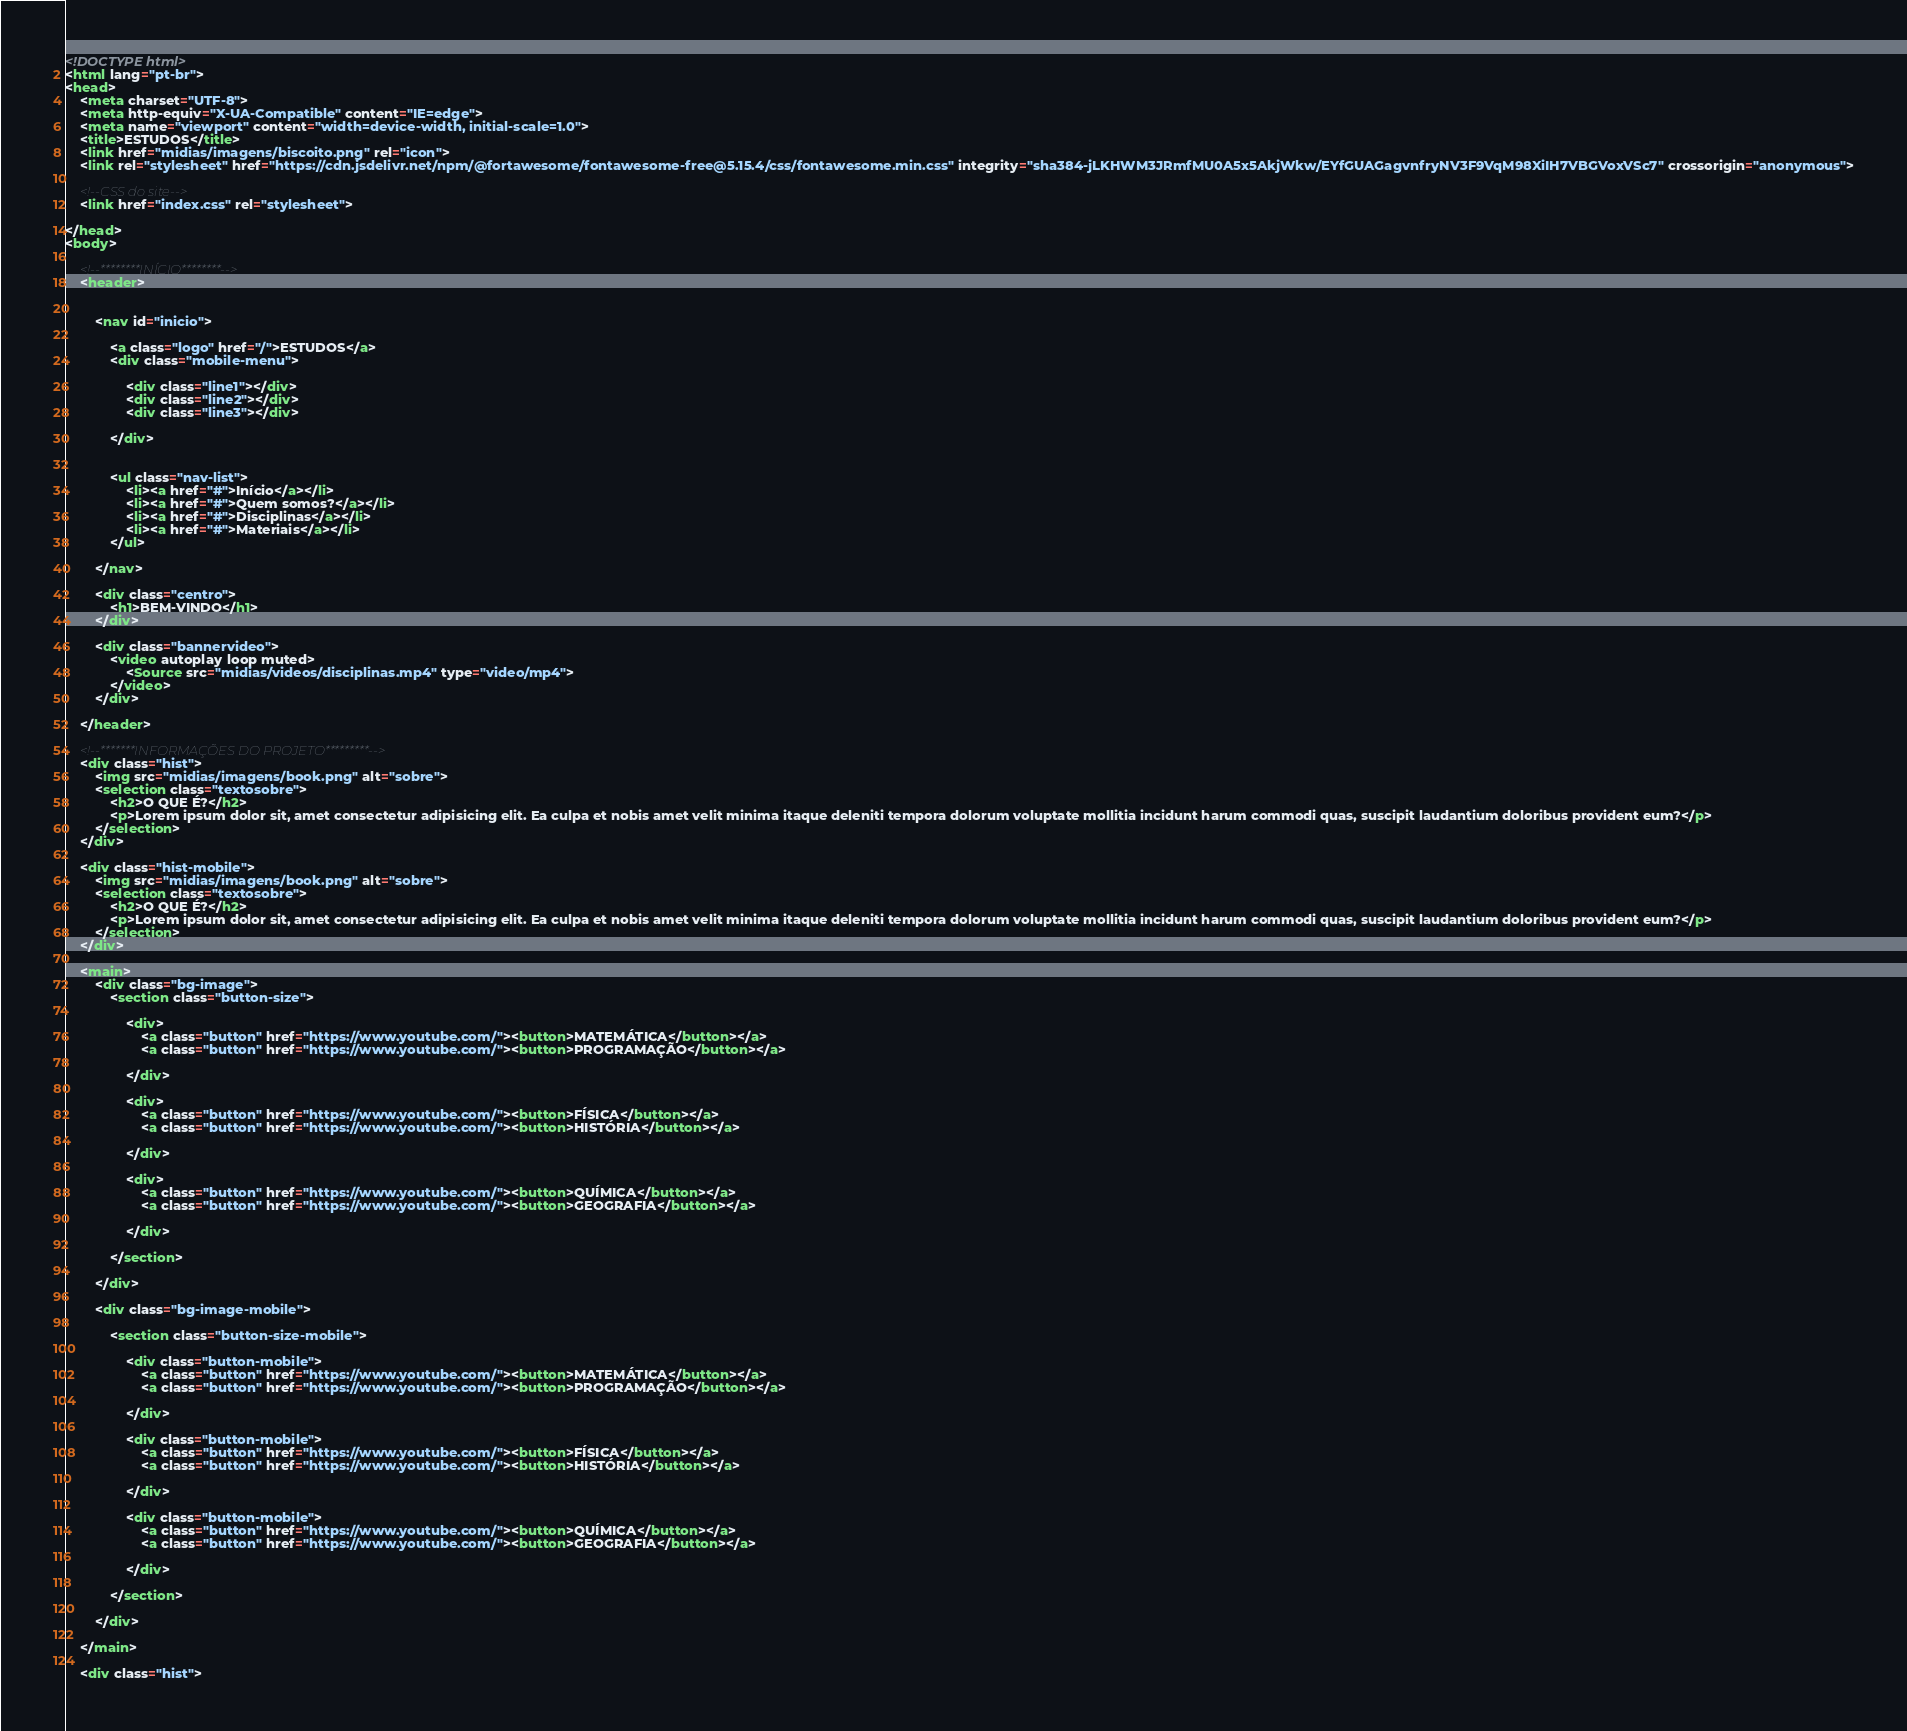<code> <loc_0><loc_0><loc_500><loc_500><_HTML_><!DOCTYPE html>
<html lang="pt-br">
<head>
    <meta charset="UTF-8">
    <meta http-equiv="X-UA-Compatible" content="IE=edge">
    <meta name="viewport" content="width=device-width, initial-scale=1.0">
    <title>ESTUDOS</title>
    <link href="midias/imagens/biscoito.png" rel="icon">
    <link rel="stylesheet" href="https://cdn.jsdelivr.net/npm/@fortawesome/fontawesome-free@5.15.4/css/fontawesome.min.css" integrity="sha384-jLKHWM3JRmfMU0A5x5AkjWkw/EYfGUAGagvnfryNV3F9VqM98XiIH7VBGVoxVSc7" crossorigin="anonymous">

    <!--CSS do site-->
    <link href="index.css" rel="stylesheet"> 

</head>
<body>

    <!--********INÍCIO********-->
    <header>


        <nav id="inicio">

            <a class="logo" href="/">ESTUDOS</a>
            <div class="mobile-menu">

                <div class="line1"></div>
                <div class="line2"></div>
                <div class="line3"></div>

            </div>
            
            
            <ul class="nav-list">
                <li><a href="#">Início</a></li>
                <li><a href="#">Quem somos?</a></li>
                <li><a href="#">Disciplinas</a></li>
                <li><a href="#">Materiais</a></li>
            </ul>

        </nav>

        <div class="centro">
            <h1>BEM-VINDO</h1>
        </div>

        <div class="bannervideo">
            <video autoplay loop muted>
                <Source src="midias/videos/disciplinas.mp4" type="video/mp4">
            </video>
        </div>

    </header>

    <!--*******INFORMAÇÕES DO PROJETO*********-->
    <div class="hist">
        <img src="midias/imagens/book.png" alt="sobre">
        <selection class="textosobre">
            <h2>O QUE É?</h2>
            <p>Lorem ipsum dolor sit, amet consectetur adipisicing elit. Ea culpa et nobis amet velit minima itaque deleniti tempora dolorum voluptate mollitia incidunt harum commodi quas, suscipit laudantium doloribus provident eum?</p>
        </selection>
    </div>

    <div class="hist-mobile">
        <img src="midias/imagens/book.png" alt="sobre">
        <selection class="textosobre">
            <h2>O QUE É?</h2>
            <p>Lorem ipsum dolor sit, amet consectetur adipisicing elit. Ea culpa et nobis amet velit minima itaque deleniti tempora dolorum voluptate mollitia incidunt harum commodi quas, suscipit laudantium doloribus provident eum?</p>
        </selection>
    </div>

    <main>
        <div class="bg-image">
            <section class="button-size">

                <div>
                    <a class="button" href="https://www.youtube.com/"><button>MATEMÁTICA</button></a>
                    <a class="button" href="https://www.youtube.com/"><button>PROGRAMAÇÃO</button></a>

                </div>

                <div>
                    <a class="button" href="https://www.youtube.com/"><button>FÍSICA</button></a>
                    <a class="button" href="https://www.youtube.com/"><button>HISTÓRIA</button></a>

                </div>

                <div>
                    <a class="button" href="https://www.youtube.com/"><button>QUÍMICA</button></a>
                    <a class="button" href="https://www.youtube.com/"><button>GEOGRAFIA</button></a>

                </div>

            </section>

        </div>

        <div class="bg-image-mobile">

            <section class="button-size-mobile">

                <div class="button-mobile">
                    <a class="button" href="https://www.youtube.com/"><button>MATEMÁTICA</button></a>
                    <a class="button" href="https://www.youtube.com/"><button>PROGRAMAÇÃO</button></a>

                </div>

                <div class="button-mobile">
                    <a class="button" href="https://www.youtube.com/"><button>FÍSICA</button></a>
                    <a class="button" href="https://www.youtube.com/"><button>HISTÓRIA</button></a>

                </div>

                <div class="button-mobile">
                    <a class="button" href="https://www.youtube.com/"><button>QUÍMICA</button></a>
                    <a class="button" href="https://www.youtube.com/"><button>GEOGRAFIA</button></a>

                </div>

            </section>

        </div>

    </main>

    <div class="hist"></code> 